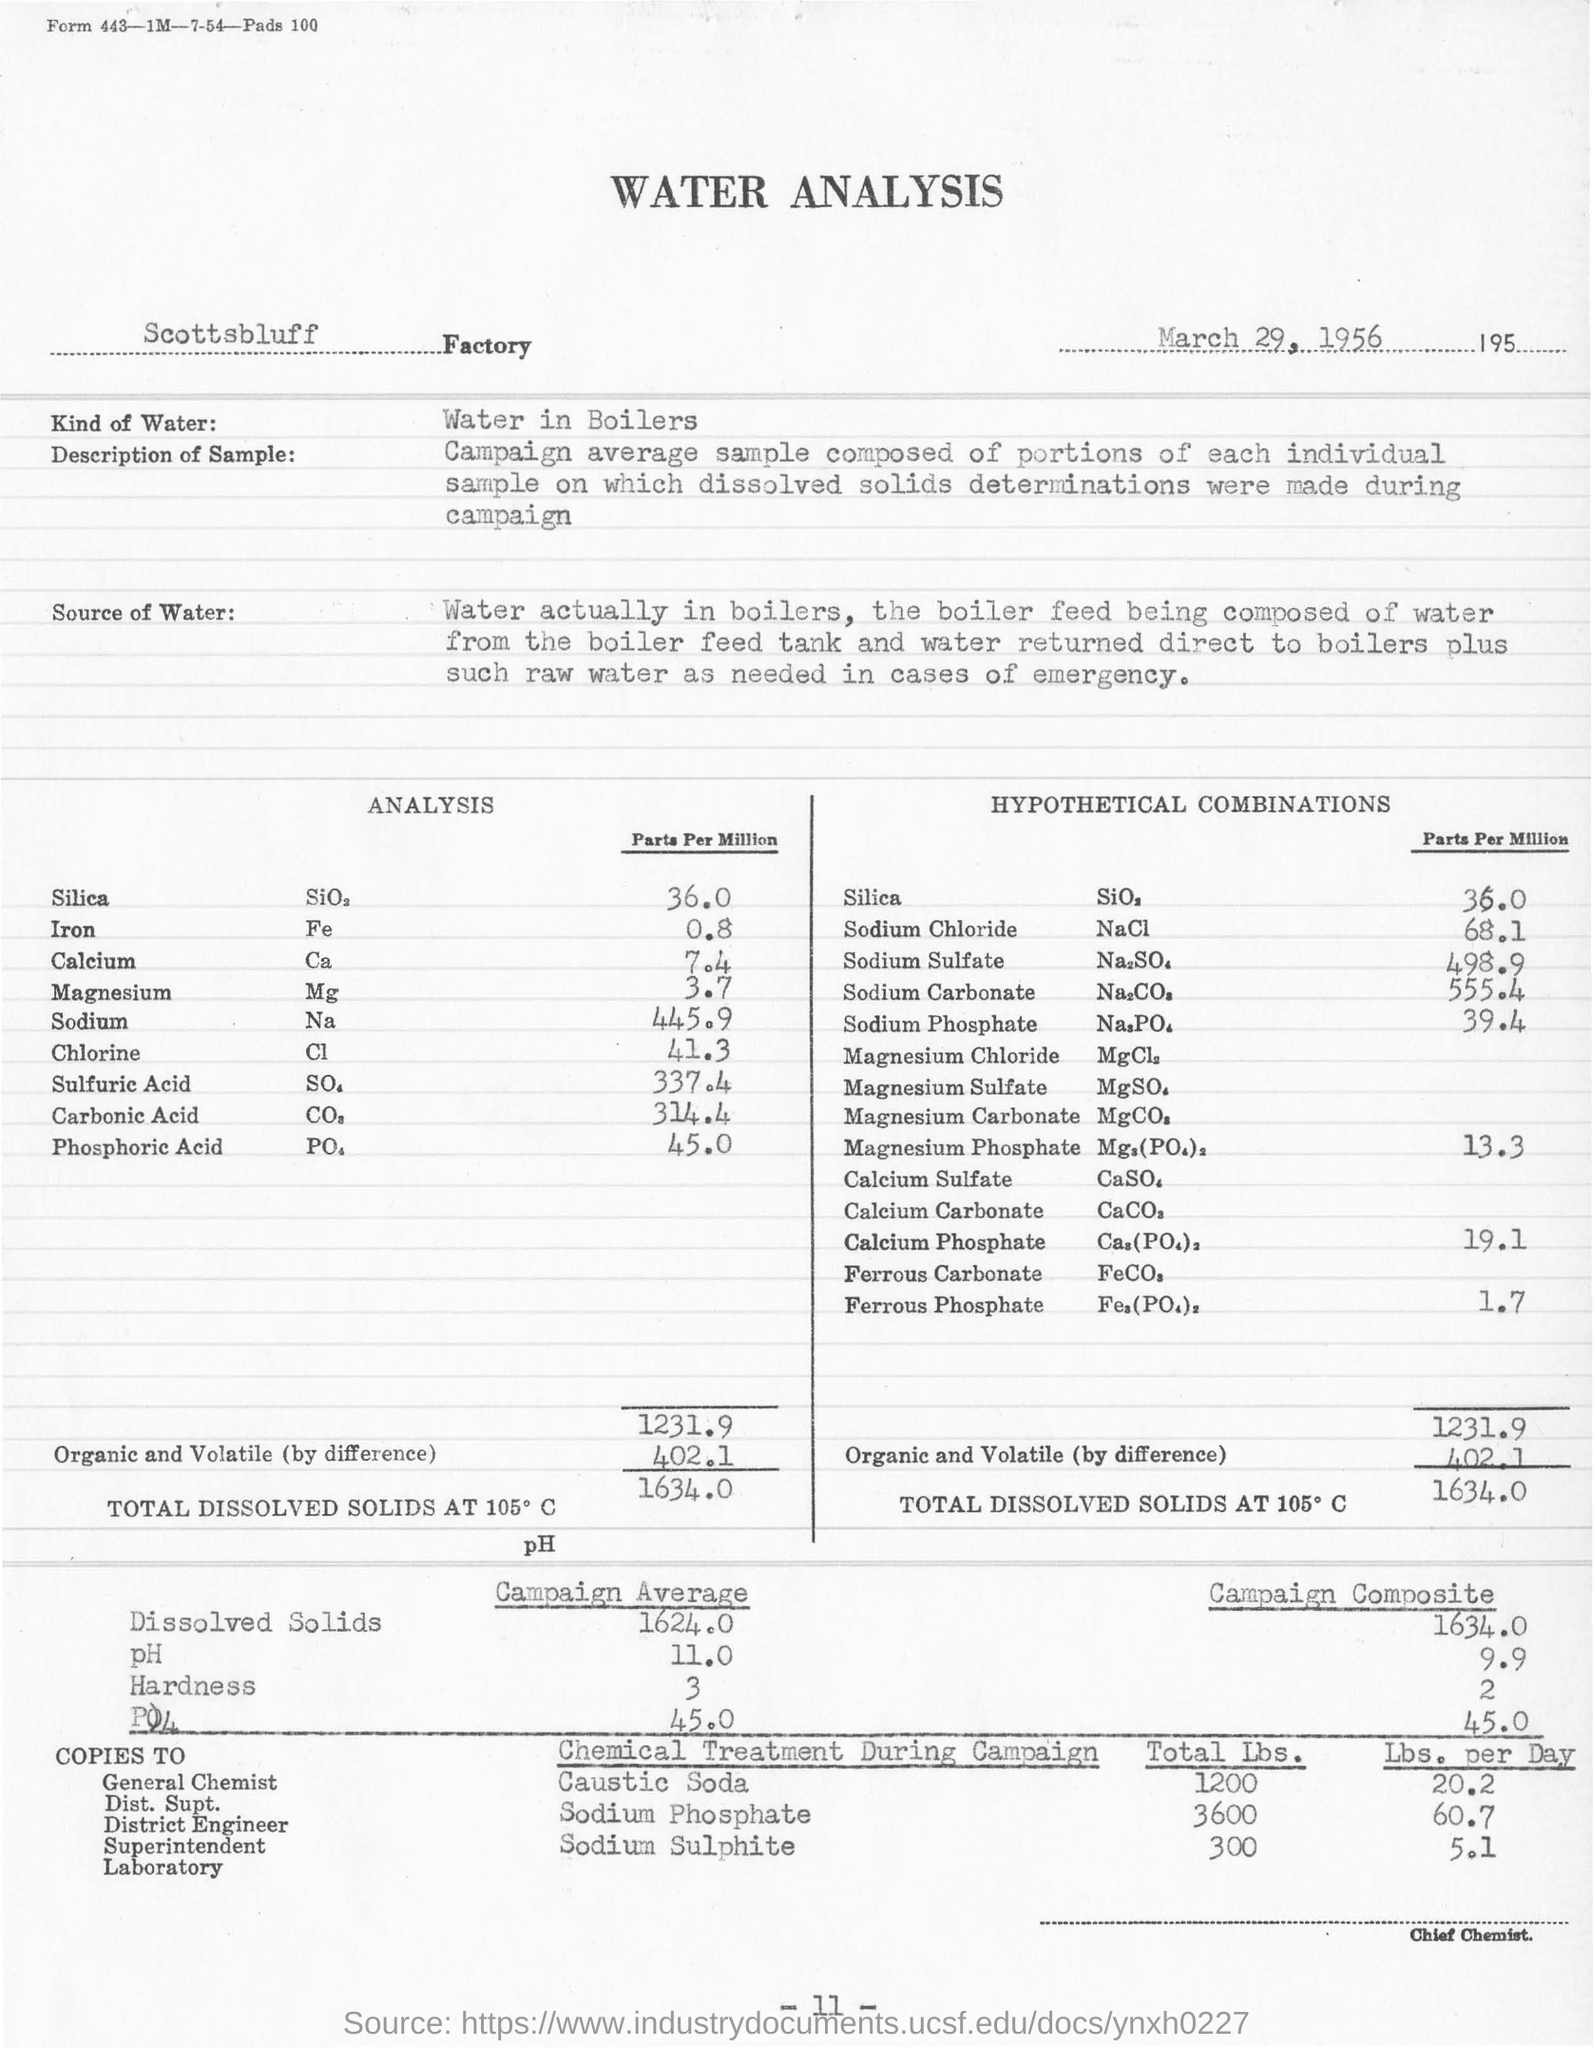When was the analysis done?
Provide a succinct answer. March 29, 1956. What is value entered in the field - "Kind of Water"?
Your answer should be very brief. Water in boilers. In total how much caustic soda was used?
Offer a very short reply. 1200. 